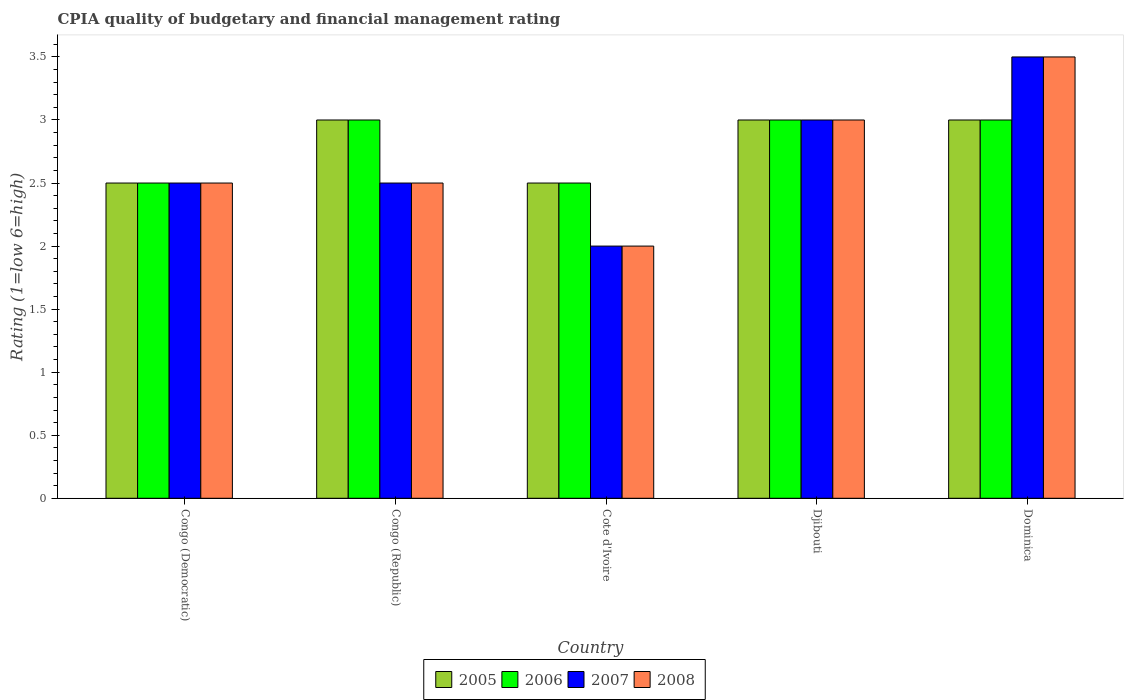How many bars are there on the 4th tick from the right?
Your response must be concise. 4. What is the label of the 4th group of bars from the left?
Provide a succinct answer. Djibouti. What is the CPIA rating in 2005 in Djibouti?
Offer a terse response. 3. In which country was the CPIA rating in 2005 maximum?
Your response must be concise. Congo (Republic). In which country was the CPIA rating in 2008 minimum?
Provide a short and direct response. Cote d'Ivoire. What is the average CPIA rating in 2007 per country?
Provide a succinct answer. 2.7. What is the difference between the CPIA rating of/in 2006 and CPIA rating of/in 2007 in Djibouti?
Keep it short and to the point. 0. In how many countries, is the CPIA rating in 2005 greater than 0.7?
Keep it short and to the point. 5. What is the ratio of the CPIA rating in 2006 in Congo (Democratic) to that in Dominica?
Offer a very short reply. 0.83. Is the CPIA rating in 2005 in Congo (Democratic) less than that in Dominica?
Keep it short and to the point. Yes. What is the difference between the highest and the second highest CPIA rating in 2007?
Give a very brief answer. 0.5. In how many countries, is the CPIA rating in 2005 greater than the average CPIA rating in 2005 taken over all countries?
Your answer should be very brief. 3. Is it the case that in every country, the sum of the CPIA rating in 2006 and CPIA rating in 2008 is greater than the sum of CPIA rating in 2005 and CPIA rating in 2007?
Offer a terse response. No. What does the 3rd bar from the left in Congo (Democratic) represents?
Give a very brief answer. 2007. What does the 4th bar from the right in Cote d'Ivoire represents?
Provide a short and direct response. 2005. Is it the case that in every country, the sum of the CPIA rating in 2005 and CPIA rating in 2008 is greater than the CPIA rating in 2006?
Ensure brevity in your answer.  Yes. How many bars are there?
Provide a short and direct response. 20. Are the values on the major ticks of Y-axis written in scientific E-notation?
Make the answer very short. No. Does the graph contain any zero values?
Provide a short and direct response. No. How are the legend labels stacked?
Make the answer very short. Horizontal. What is the title of the graph?
Offer a terse response. CPIA quality of budgetary and financial management rating. What is the Rating (1=low 6=high) in 2007 in Congo (Democratic)?
Your response must be concise. 2.5. What is the Rating (1=low 6=high) in 2008 in Congo (Democratic)?
Your answer should be very brief. 2.5. What is the Rating (1=low 6=high) of 2007 in Congo (Republic)?
Give a very brief answer. 2.5. What is the Rating (1=low 6=high) of 2008 in Congo (Republic)?
Ensure brevity in your answer.  2.5. What is the Rating (1=low 6=high) of 2007 in Cote d'Ivoire?
Your response must be concise. 2. What is the Rating (1=low 6=high) of 2008 in Cote d'Ivoire?
Your response must be concise. 2. What is the Rating (1=low 6=high) of 2005 in Djibouti?
Your answer should be compact. 3. What is the Rating (1=low 6=high) in 2006 in Djibouti?
Your answer should be compact. 3. What is the Rating (1=low 6=high) of 2007 in Djibouti?
Your answer should be compact. 3. What is the Rating (1=low 6=high) in 2006 in Dominica?
Your response must be concise. 3. What is the Rating (1=low 6=high) in 2008 in Dominica?
Provide a short and direct response. 3.5. Across all countries, what is the maximum Rating (1=low 6=high) in 2005?
Your answer should be very brief. 3. Across all countries, what is the maximum Rating (1=low 6=high) of 2006?
Your answer should be very brief. 3. Across all countries, what is the maximum Rating (1=low 6=high) in 2007?
Your answer should be very brief. 3.5. Across all countries, what is the minimum Rating (1=low 6=high) in 2005?
Offer a very short reply. 2.5. Across all countries, what is the minimum Rating (1=low 6=high) of 2008?
Offer a terse response. 2. What is the total Rating (1=low 6=high) in 2005 in the graph?
Keep it short and to the point. 14. What is the total Rating (1=low 6=high) in 2007 in the graph?
Keep it short and to the point. 13.5. What is the total Rating (1=low 6=high) in 2008 in the graph?
Your response must be concise. 13.5. What is the difference between the Rating (1=low 6=high) in 2005 in Congo (Democratic) and that in Congo (Republic)?
Your answer should be very brief. -0.5. What is the difference between the Rating (1=low 6=high) of 2007 in Congo (Democratic) and that in Congo (Republic)?
Provide a succinct answer. 0. What is the difference between the Rating (1=low 6=high) in 2006 in Congo (Democratic) and that in Cote d'Ivoire?
Make the answer very short. 0. What is the difference between the Rating (1=low 6=high) of 2008 in Congo (Democratic) and that in Cote d'Ivoire?
Your answer should be compact. 0.5. What is the difference between the Rating (1=low 6=high) in 2005 in Congo (Democratic) and that in Djibouti?
Offer a very short reply. -0.5. What is the difference between the Rating (1=low 6=high) of 2007 in Congo (Democratic) and that in Djibouti?
Ensure brevity in your answer.  -0.5. What is the difference between the Rating (1=low 6=high) of 2008 in Congo (Democratic) and that in Djibouti?
Offer a terse response. -0.5. What is the difference between the Rating (1=low 6=high) in 2006 in Congo (Democratic) and that in Dominica?
Give a very brief answer. -0.5. What is the difference between the Rating (1=low 6=high) of 2008 in Congo (Democratic) and that in Dominica?
Your answer should be compact. -1. What is the difference between the Rating (1=low 6=high) of 2006 in Congo (Republic) and that in Cote d'Ivoire?
Your answer should be very brief. 0.5. What is the difference between the Rating (1=low 6=high) of 2007 in Congo (Republic) and that in Cote d'Ivoire?
Provide a succinct answer. 0.5. What is the difference between the Rating (1=low 6=high) in 2005 in Congo (Republic) and that in Djibouti?
Ensure brevity in your answer.  0. What is the difference between the Rating (1=low 6=high) in 2006 in Congo (Republic) and that in Djibouti?
Your answer should be very brief. 0. What is the difference between the Rating (1=low 6=high) of 2008 in Congo (Republic) and that in Djibouti?
Your answer should be very brief. -0.5. What is the difference between the Rating (1=low 6=high) of 2005 in Congo (Republic) and that in Dominica?
Make the answer very short. 0. What is the difference between the Rating (1=low 6=high) of 2006 in Congo (Republic) and that in Dominica?
Give a very brief answer. 0. What is the difference between the Rating (1=low 6=high) of 2007 in Congo (Republic) and that in Dominica?
Provide a short and direct response. -1. What is the difference between the Rating (1=low 6=high) in 2005 in Cote d'Ivoire and that in Djibouti?
Offer a very short reply. -0.5. What is the difference between the Rating (1=low 6=high) in 2006 in Cote d'Ivoire and that in Djibouti?
Ensure brevity in your answer.  -0.5. What is the difference between the Rating (1=low 6=high) of 2008 in Cote d'Ivoire and that in Djibouti?
Offer a terse response. -1. What is the difference between the Rating (1=low 6=high) in 2007 in Cote d'Ivoire and that in Dominica?
Offer a very short reply. -1.5. What is the difference between the Rating (1=low 6=high) of 2006 in Djibouti and that in Dominica?
Offer a very short reply. 0. What is the difference between the Rating (1=low 6=high) of 2005 in Congo (Democratic) and the Rating (1=low 6=high) of 2006 in Congo (Republic)?
Ensure brevity in your answer.  -0.5. What is the difference between the Rating (1=low 6=high) of 2005 in Congo (Democratic) and the Rating (1=low 6=high) of 2007 in Congo (Republic)?
Give a very brief answer. 0. What is the difference between the Rating (1=low 6=high) of 2006 in Congo (Democratic) and the Rating (1=low 6=high) of 2008 in Congo (Republic)?
Your answer should be very brief. 0. What is the difference between the Rating (1=low 6=high) of 2007 in Congo (Democratic) and the Rating (1=low 6=high) of 2008 in Congo (Republic)?
Offer a terse response. 0. What is the difference between the Rating (1=low 6=high) in 2005 in Congo (Democratic) and the Rating (1=low 6=high) in 2006 in Cote d'Ivoire?
Offer a very short reply. 0. What is the difference between the Rating (1=low 6=high) of 2005 in Congo (Democratic) and the Rating (1=low 6=high) of 2007 in Cote d'Ivoire?
Give a very brief answer. 0.5. What is the difference between the Rating (1=low 6=high) in 2005 in Congo (Democratic) and the Rating (1=low 6=high) in 2008 in Cote d'Ivoire?
Your response must be concise. 0.5. What is the difference between the Rating (1=low 6=high) in 2006 in Congo (Democratic) and the Rating (1=low 6=high) in 2008 in Cote d'Ivoire?
Keep it short and to the point. 0.5. What is the difference between the Rating (1=low 6=high) of 2005 in Congo (Democratic) and the Rating (1=low 6=high) of 2008 in Djibouti?
Provide a succinct answer. -0.5. What is the difference between the Rating (1=low 6=high) of 2006 in Congo (Democratic) and the Rating (1=low 6=high) of 2007 in Djibouti?
Make the answer very short. -0.5. What is the difference between the Rating (1=low 6=high) in 2006 in Congo (Democratic) and the Rating (1=low 6=high) in 2008 in Djibouti?
Offer a very short reply. -0.5. What is the difference between the Rating (1=low 6=high) of 2005 in Congo (Democratic) and the Rating (1=low 6=high) of 2007 in Dominica?
Your response must be concise. -1. What is the difference between the Rating (1=low 6=high) in 2005 in Congo (Democratic) and the Rating (1=low 6=high) in 2008 in Dominica?
Provide a short and direct response. -1. What is the difference between the Rating (1=low 6=high) of 2006 in Congo (Democratic) and the Rating (1=low 6=high) of 2007 in Dominica?
Make the answer very short. -1. What is the difference between the Rating (1=low 6=high) of 2006 in Congo (Republic) and the Rating (1=low 6=high) of 2007 in Cote d'Ivoire?
Make the answer very short. 1. What is the difference between the Rating (1=low 6=high) in 2006 in Congo (Republic) and the Rating (1=low 6=high) in 2008 in Cote d'Ivoire?
Give a very brief answer. 1. What is the difference between the Rating (1=low 6=high) in 2007 in Congo (Republic) and the Rating (1=low 6=high) in 2008 in Cote d'Ivoire?
Your response must be concise. 0.5. What is the difference between the Rating (1=low 6=high) of 2005 in Congo (Republic) and the Rating (1=low 6=high) of 2007 in Djibouti?
Provide a short and direct response. 0. What is the difference between the Rating (1=low 6=high) of 2006 in Congo (Republic) and the Rating (1=low 6=high) of 2007 in Djibouti?
Offer a very short reply. 0. What is the difference between the Rating (1=low 6=high) of 2006 in Congo (Republic) and the Rating (1=low 6=high) of 2008 in Djibouti?
Ensure brevity in your answer.  0. What is the difference between the Rating (1=low 6=high) in 2005 in Congo (Republic) and the Rating (1=low 6=high) in 2006 in Dominica?
Provide a succinct answer. 0. What is the difference between the Rating (1=low 6=high) in 2006 in Congo (Republic) and the Rating (1=low 6=high) in 2007 in Dominica?
Offer a terse response. -0.5. What is the difference between the Rating (1=low 6=high) in 2005 in Cote d'Ivoire and the Rating (1=low 6=high) in 2006 in Djibouti?
Your answer should be compact. -0.5. What is the difference between the Rating (1=low 6=high) in 2005 in Cote d'Ivoire and the Rating (1=low 6=high) in 2007 in Djibouti?
Keep it short and to the point. -0.5. What is the difference between the Rating (1=low 6=high) of 2005 in Cote d'Ivoire and the Rating (1=low 6=high) of 2007 in Dominica?
Give a very brief answer. -1. What is the difference between the Rating (1=low 6=high) of 2005 in Cote d'Ivoire and the Rating (1=low 6=high) of 2008 in Dominica?
Your answer should be compact. -1. What is the difference between the Rating (1=low 6=high) in 2005 in Djibouti and the Rating (1=low 6=high) in 2006 in Dominica?
Your answer should be compact. 0. What is the difference between the Rating (1=low 6=high) in 2005 in Djibouti and the Rating (1=low 6=high) in 2008 in Dominica?
Provide a succinct answer. -0.5. What is the average Rating (1=low 6=high) of 2006 per country?
Ensure brevity in your answer.  2.8. What is the average Rating (1=low 6=high) of 2007 per country?
Your response must be concise. 2.7. What is the average Rating (1=low 6=high) in 2008 per country?
Provide a short and direct response. 2.7. What is the difference between the Rating (1=low 6=high) in 2005 and Rating (1=low 6=high) in 2006 in Congo (Democratic)?
Make the answer very short. 0. What is the difference between the Rating (1=low 6=high) in 2005 and Rating (1=low 6=high) in 2007 in Congo (Democratic)?
Give a very brief answer. 0. What is the difference between the Rating (1=low 6=high) in 2005 and Rating (1=low 6=high) in 2007 in Congo (Republic)?
Keep it short and to the point. 0.5. What is the difference between the Rating (1=low 6=high) in 2006 and Rating (1=low 6=high) in 2007 in Congo (Republic)?
Your answer should be compact. 0.5. What is the difference between the Rating (1=low 6=high) of 2005 and Rating (1=low 6=high) of 2007 in Cote d'Ivoire?
Offer a terse response. 0.5. What is the difference between the Rating (1=low 6=high) of 2005 and Rating (1=low 6=high) of 2008 in Cote d'Ivoire?
Make the answer very short. 0.5. What is the difference between the Rating (1=low 6=high) in 2006 and Rating (1=low 6=high) in 2007 in Cote d'Ivoire?
Give a very brief answer. 0.5. What is the difference between the Rating (1=low 6=high) in 2007 and Rating (1=low 6=high) in 2008 in Cote d'Ivoire?
Your answer should be compact. 0. What is the difference between the Rating (1=low 6=high) in 2005 and Rating (1=low 6=high) in 2007 in Djibouti?
Make the answer very short. 0. What is the difference between the Rating (1=low 6=high) of 2006 and Rating (1=low 6=high) of 2007 in Djibouti?
Provide a short and direct response. 0. What is the difference between the Rating (1=low 6=high) of 2006 and Rating (1=low 6=high) of 2008 in Djibouti?
Provide a short and direct response. 0. What is the difference between the Rating (1=low 6=high) in 2005 and Rating (1=low 6=high) in 2006 in Dominica?
Your response must be concise. 0. What is the difference between the Rating (1=low 6=high) of 2005 and Rating (1=low 6=high) of 2008 in Dominica?
Your answer should be compact. -0.5. What is the difference between the Rating (1=low 6=high) in 2006 and Rating (1=low 6=high) in 2008 in Dominica?
Give a very brief answer. -0.5. What is the ratio of the Rating (1=low 6=high) of 2005 in Congo (Democratic) to that in Congo (Republic)?
Make the answer very short. 0.83. What is the ratio of the Rating (1=low 6=high) of 2005 in Congo (Democratic) to that in Cote d'Ivoire?
Your response must be concise. 1. What is the ratio of the Rating (1=low 6=high) in 2007 in Congo (Democratic) to that in Cote d'Ivoire?
Your answer should be compact. 1.25. What is the ratio of the Rating (1=low 6=high) in 2007 in Congo (Democratic) to that in Djibouti?
Give a very brief answer. 0.83. What is the ratio of the Rating (1=low 6=high) in 2005 in Congo (Democratic) to that in Dominica?
Offer a very short reply. 0.83. What is the ratio of the Rating (1=low 6=high) of 2007 in Congo (Democratic) to that in Dominica?
Provide a short and direct response. 0.71. What is the ratio of the Rating (1=low 6=high) in 2008 in Congo (Democratic) to that in Dominica?
Offer a terse response. 0.71. What is the ratio of the Rating (1=low 6=high) of 2005 in Congo (Republic) to that in Cote d'Ivoire?
Your response must be concise. 1.2. What is the ratio of the Rating (1=low 6=high) in 2006 in Congo (Republic) to that in Cote d'Ivoire?
Your answer should be very brief. 1.2. What is the ratio of the Rating (1=low 6=high) in 2007 in Congo (Republic) to that in Cote d'Ivoire?
Offer a very short reply. 1.25. What is the ratio of the Rating (1=low 6=high) in 2006 in Congo (Republic) to that in Djibouti?
Keep it short and to the point. 1. What is the ratio of the Rating (1=low 6=high) of 2007 in Congo (Republic) to that in Djibouti?
Your response must be concise. 0.83. What is the ratio of the Rating (1=low 6=high) of 2007 in Congo (Republic) to that in Dominica?
Offer a very short reply. 0.71. What is the ratio of the Rating (1=low 6=high) of 2006 in Cote d'Ivoire to that in Djibouti?
Provide a succinct answer. 0.83. What is the ratio of the Rating (1=low 6=high) of 2007 in Cote d'Ivoire to that in Djibouti?
Keep it short and to the point. 0.67. What is the ratio of the Rating (1=low 6=high) in 2005 in Cote d'Ivoire to that in Dominica?
Your answer should be compact. 0.83. What is the ratio of the Rating (1=low 6=high) in 2008 in Cote d'Ivoire to that in Dominica?
Offer a terse response. 0.57. What is the ratio of the Rating (1=low 6=high) in 2005 in Djibouti to that in Dominica?
Provide a short and direct response. 1. What is the ratio of the Rating (1=low 6=high) of 2007 in Djibouti to that in Dominica?
Your response must be concise. 0.86. What is the ratio of the Rating (1=low 6=high) of 2008 in Djibouti to that in Dominica?
Your answer should be compact. 0.86. What is the difference between the highest and the second highest Rating (1=low 6=high) in 2007?
Keep it short and to the point. 0.5. What is the difference between the highest and the lowest Rating (1=low 6=high) of 2005?
Offer a very short reply. 0.5. What is the difference between the highest and the lowest Rating (1=low 6=high) of 2007?
Make the answer very short. 1.5. What is the difference between the highest and the lowest Rating (1=low 6=high) of 2008?
Your response must be concise. 1.5. 